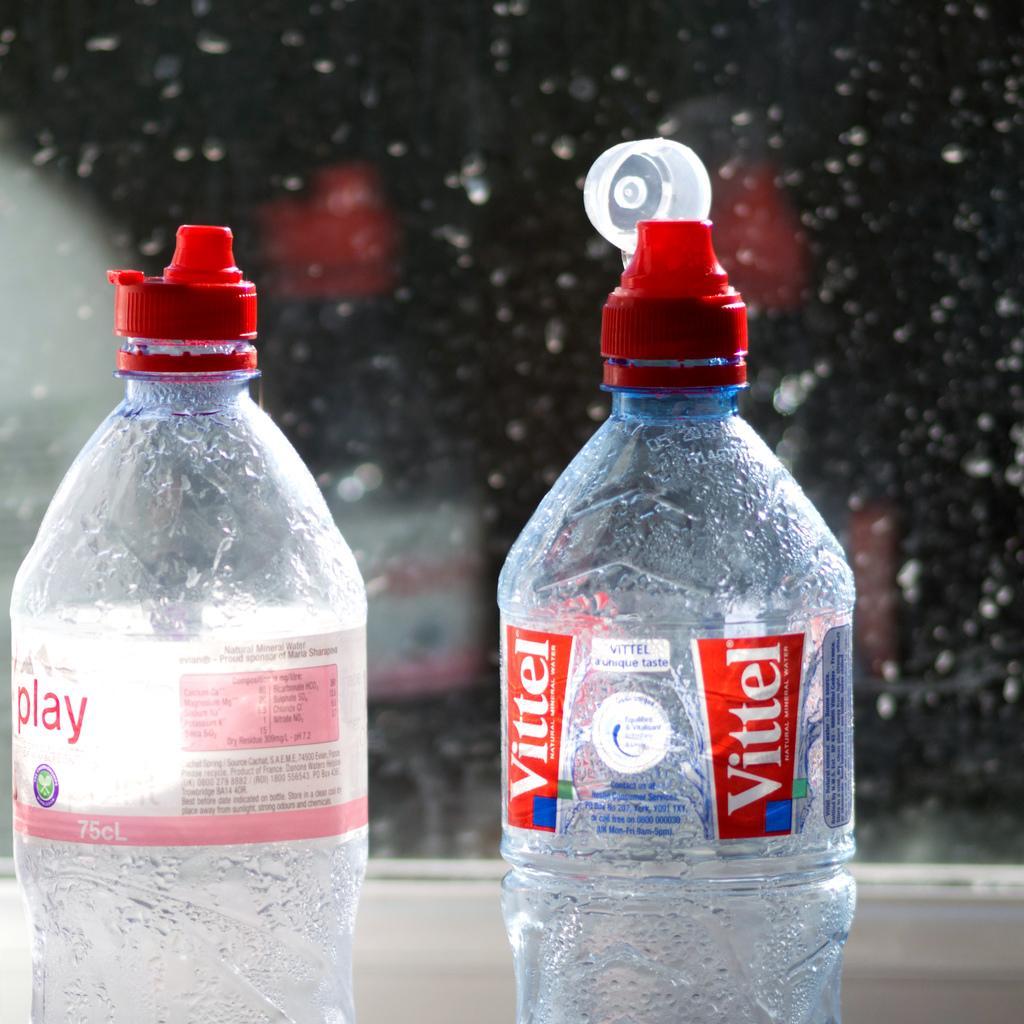Please provide a concise description of this image. In the image we can see there are two bottles which are kept in front and behind the bottles the image is blur. 